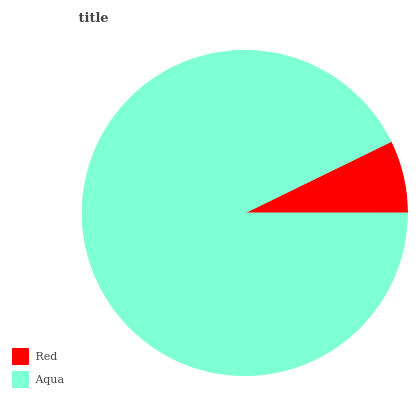Is Red the minimum?
Answer yes or no. Yes. Is Aqua the maximum?
Answer yes or no. Yes. Is Aqua the minimum?
Answer yes or no. No. Is Aqua greater than Red?
Answer yes or no. Yes. Is Red less than Aqua?
Answer yes or no. Yes. Is Red greater than Aqua?
Answer yes or no. No. Is Aqua less than Red?
Answer yes or no. No. Is Aqua the high median?
Answer yes or no. Yes. Is Red the low median?
Answer yes or no. Yes. Is Red the high median?
Answer yes or no. No. Is Aqua the low median?
Answer yes or no. No. 